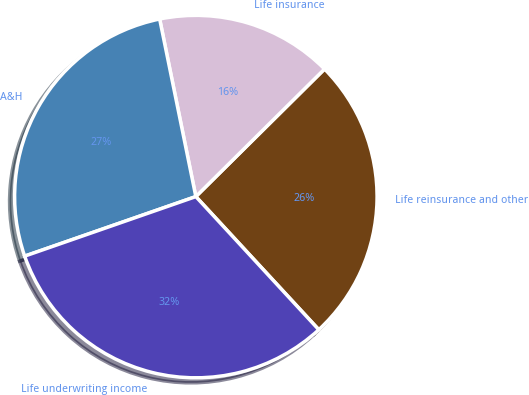<chart> <loc_0><loc_0><loc_500><loc_500><pie_chart><fcel>Life reinsurance and other<fcel>Life insurance<fcel>A&H<fcel>Life underwriting income<nl><fcel>25.56%<fcel>15.77%<fcel>27.13%<fcel>31.54%<nl></chart> 